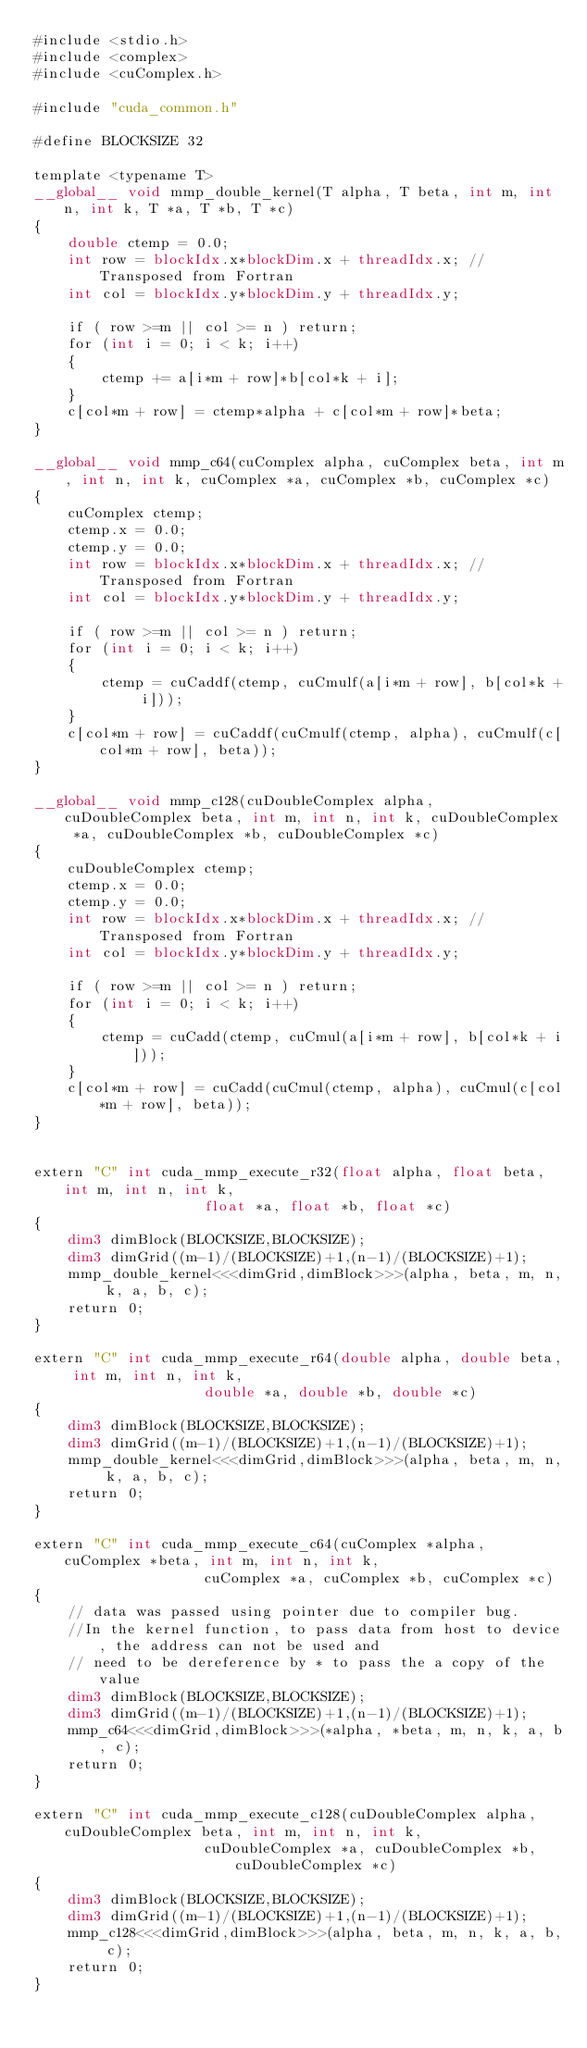<code> <loc_0><loc_0><loc_500><loc_500><_Cuda_>#include <stdio.h>
#include <complex>
#include <cuComplex.h>

#include "cuda_common.h"

#define BLOCKSIZE 32

template <typename T>
__global__ void mmp_double_kernel(T alpha, T beta, int m, int n, int k, T *a, T *b, T *c)
{
    double ctemp = 0.0;
    int row = blockIdx.x*blockDim.x + threadIdx.x; // Transposed from Fortran
    int col = blockIdx.y*blockDim.y + threadIdx.y;

    if ( row >=m || col >= n ) return;
    for (int i = 0; i < k; i++)
    {
        ctemp += a[i*m + row]*b[col*k + i];
    }
    c[col*m + row] = ctemp*alpha + c[col*m + row]*beta;
}

__global__ void mmp_c64(cuComplex alpha, cuComplex beta, int m, int n, int k, cuComplex *a, cuComplex *b, cuComplex *c)
{
    cuComplex ctemp;
    ctemp.x = 0.0;
    ctemp.y = 0.0;
    int row = blockIdx.x*blockDim.x + threadIdx.x; // Transposed from Fortran
    int col = blockIdx.y*blockDim.y + threadIdx.y;

    if ( row >=m || col >= n ) return;
    for (int i = 0; i < k; i++)
    {
        ctemp = cuCaddf(ctemp, cuCmulf(a[i*m + row], b[col*k + i]));
    }
    c[col*m + row] = cuCaddf(cuCmulf(ctemp, alpha), cuCmulf(c[col*m + row], beta));
} 

__global__ void mmp_c128(cuDoubleComplex alpha, cuDoubleComplex beta, int m, int n, int k, cuDoubleComplex *a, cuDoubleComplex *b, cuDoubleComplex *c)
{
    cuDoubleComplex ctemp;
    ctemp.x = 0.0;
    ctemp.y = 0.0;
    int row = blockIdx.x*blockDim.x + threadIdx.x; // Transposed from Fortran
    int col = blockIdx.y*blockDim.y + threadIdx.y;

    if ( row >=m || col >= n ) return;
    for (int i = 0; i < k; i++)
    {
        ctemp = cuCadd(ctemp, cuCmul(a[i*m + row], b[col*k + i]));
    }
    c[col*m + row] = cuCadd(cuCmul(ctemp, alpha), cuCmul(c[col*m + row], beta));
}


extern "C" int cuda_mmp_execute_r32(float alpha, float beta, int m, int n, int k,
                    float *a, float *b, float *c)
{
    dim3 dimBlock(BLOCKSIZE,BLOCKSIZE);
    dim3 dimGrid((m-1)/(BLOCKSIZE)+1,(n-1)/(BLOCKSIZE)+1);
    mmp_double_kernel<<<dimGrid,dimBlock>>>(alpha, beta, m, n, k, a, b, c);
    return 0;
}

extern "C" int cuda_mmp_execute_r64(double alpha, double beta, int m, int n, int k,
                    double *a, double *b, double *c)
{
    dim3 dimBlock(BLOCKSIZE,BLOCKSIZE);
    dim3 dimGrid((m-1)/(BLOCKSIZE)+1,(n-1)/(BLOCKSIZE)+1);
    mmp_double_kernel<<<dimGrid,dimBlock>>>(alpha, beta, m, n, k, a, b, c);
    return 0;
}

extern "C" int cuda_mmp_execute_c64(cuComplex *alpha, cuComplex *beta, int m, int n, int k,
                    cuComplex *a, cuComplex *b, cuComplex *c)
{
    // data was passed using pointer due to compiler bug. 
    //In the kernel function, to pass data from host to device, the address can not be used and 
    // need to be dereference by * to pass the a copy of the value
    dim3 dimBlock(BLOCKSIZE,BLOCKSIZE);
    dim3 dimGrid((m-1)/(BLOCKSIZE)+1,(n-1)/(BLOCKSIZE)+1);
    mmp_c64<<<dimGrid,dimBlock>>>(*alpha, *beta, m, n, k, a, b, c);
    return 0;
}

extern "C" int cuda_mmp_execute_c128(cuDoubleComplex alpha, cuDoubleComplex beta, int m, int n, int k,
                    cuDoubleComplex *a, cuDoubleComplex *b, cuDoubleComplex *c)
{
    dim3 dimBlock(BLOCKSIZE,BLOCKSIZE);
    dim3 dimGrid((m-1)/(BLOCKSIZE)+1,(n-1)/(BLOCKSIZE)+1);
    mmp_c128<<<dimGrid,dimBlock>>>(alpha, beta, m, n, k, a, b, c);
    return 0;
}
</code> 